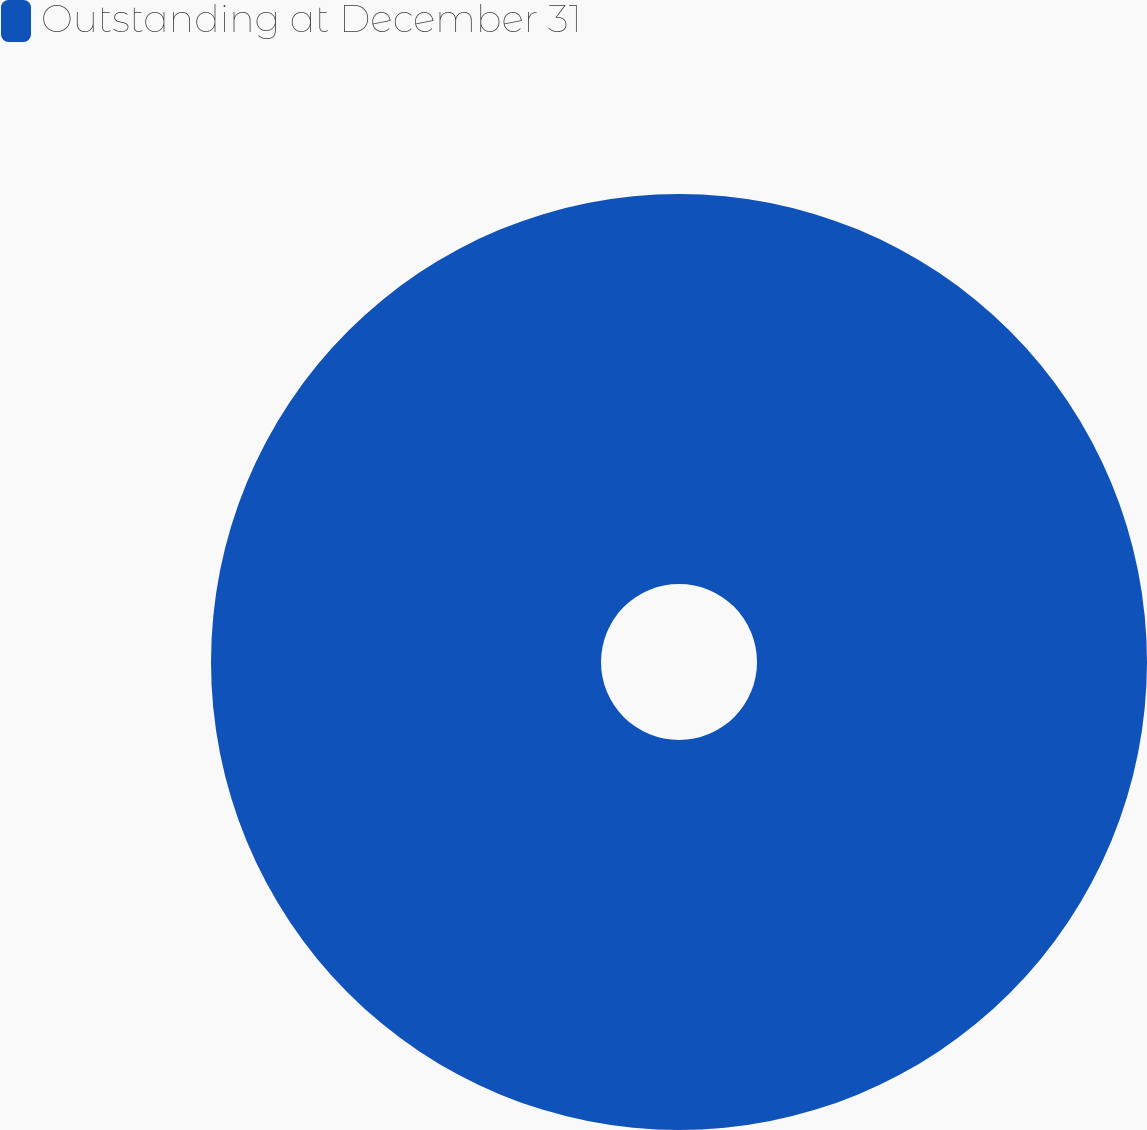Convert chart to OTSL. <chart><loc_0><loc_0><loc_500><loc_500><pie_chart><fcel>Outstanding at December 31<nl><fcel>100.0%<nl></chart> 